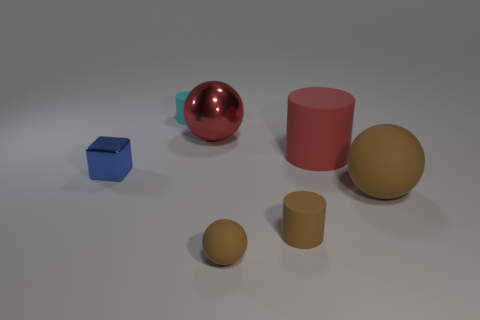Subtract 1 balls. How many balls are left? 2 Subtract all brown matte balls. How many balls are left? 1 Subtract all red spheres. How many spheres are left? 2 Subtract all cylinders. How many objects are left? 4 Subtract all tiny yellow spheres. Subtract all brown things. How many objects are left? 4 Add 6 cyan rubber cylinders. How many cyan rubber cylinders are left? 7 Add 6 blue blocks. How many blue blocks exist? 7 Add 1 yellow spheres. How many objects exist? 8 Subtract 0 yellow cylinders. How many objects are left? 7 Subtract all purple balls. Subtract all gray cubes. How many balls are left? 3 